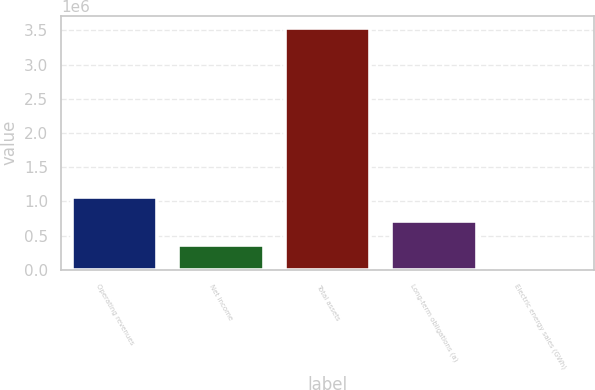Convert chart. <chart><loc_0><loc_0><loc_500><loc_500><bar_chart><fcel>Operating revenues<fcel>Net income<fcel>Total assets<fcel>Long-term obligations (a)<fcel>Electric energy sales (GWh)<nl><fcel>1.06808e+06<fcel>362556<fcel>3.53741e+06<fcel>715318<fcel>9794<nl></chart> 